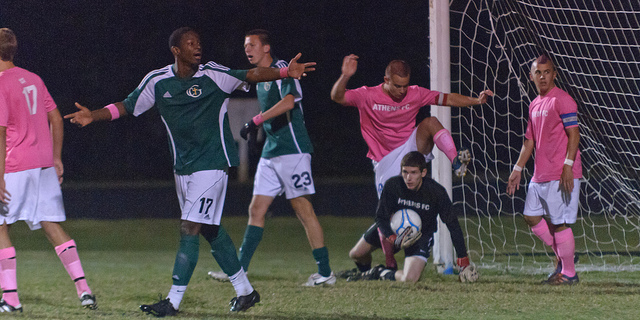Please identify all text content in this image. 17 23 